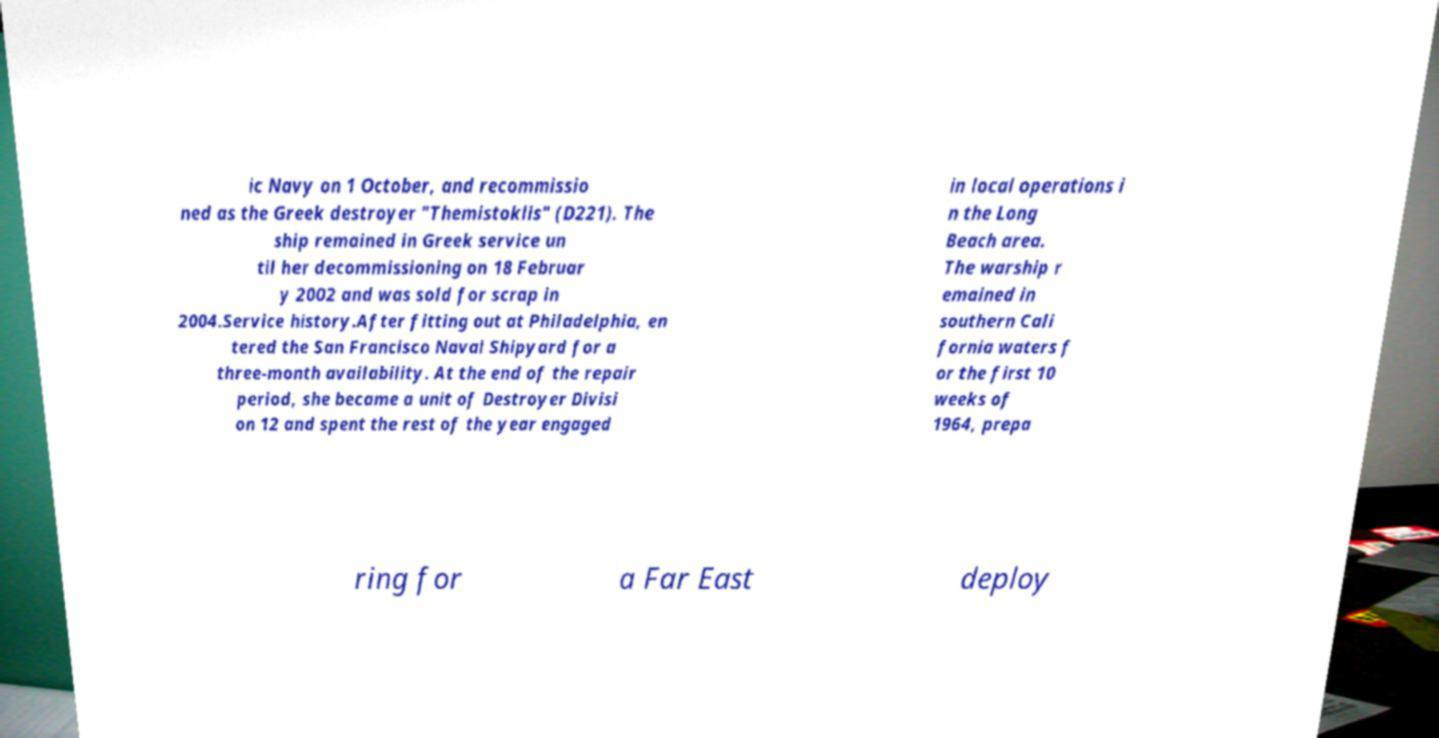For documentation purposes, I need the text within this image transcribed. Could you provide that? ic Navy on 1 October, and recommissio ned as the Greek destroyer "Themistoklis" (D221). The ship remained in Greek service un til her decommissioning on 18 Februar y 2002 and was sold for scrap in 2004.Service history.After fitting out at Philadelphia, en tered the San Francisco Naval Shipyard for a three-month availability. At the end of the repair period, she became a unit of Destroyer Divisi on 12 and spent the rest of the year engaged in local operations i n the Long Beach area. The warship r emained in southern Cali fornia waters f or the first 10 weeks of 1964, prepa ring for a Far East deploy 